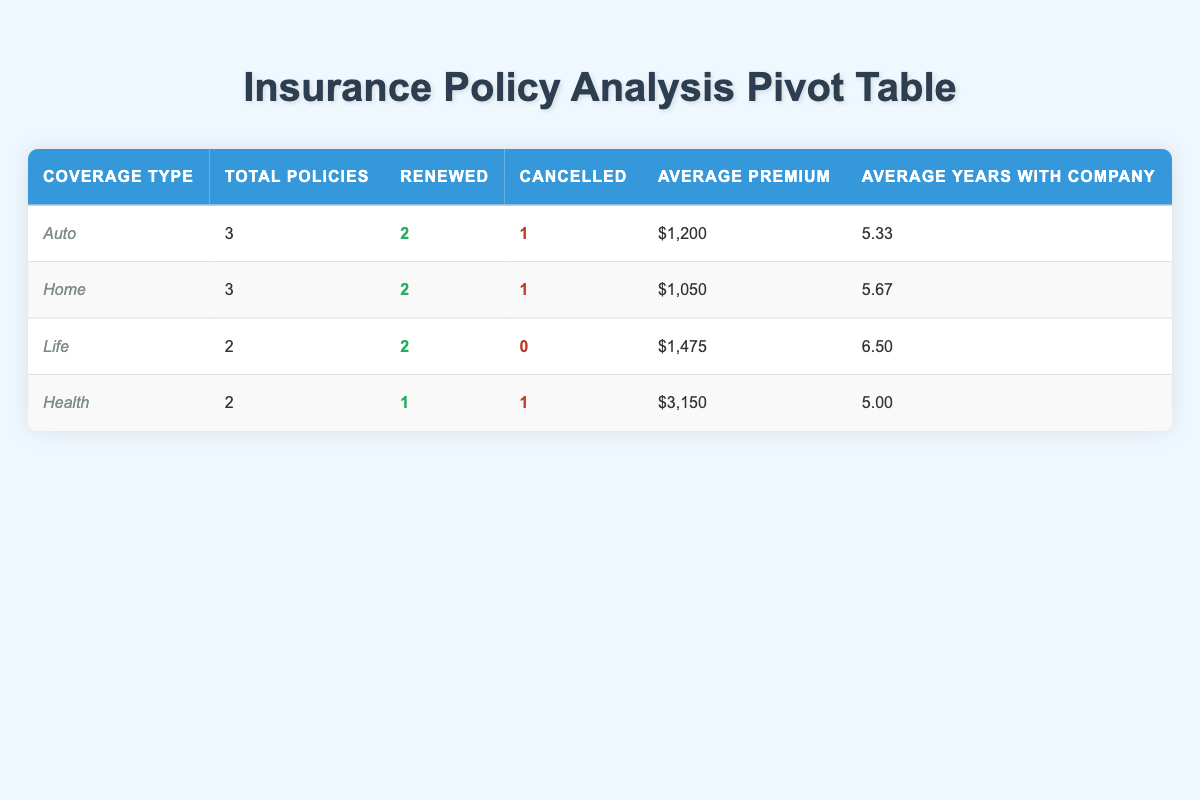What is the total number of policies for Auto coverage? In the table, we can find the row for Auto coverage and see the column labeled "Total Policies," which shows the total number of policies. It states that there are 3 policies for Auto coverage.
Answer: 3 What is the average annual premium for Life insurance? Looking at the row for Life in the table, the column "Average Premium" shows an amount of $1,475. Therefore, that is the average annual premium for Life insurance.
Answer: $1,475 Is the cancellation rate higher for Health insurance compared to Auto insurance? To determine if the cancellation rate for Health is higher than Auto, we compare the "Cancelled" columns. Health has 1 cancelled policy out of 2 total, which gives a cancellation rate of 50%. Auto has 1 cancelled policy out of 3 total, which gives a cancellation rate of approximately 33.33%. Since 50% is greater than 33.33%, the cancellation rate for Health is higher.
Answer: Yes What is the difference in the number of renewed policies between Home and Health insurance? Looking at the renewed policies in the table, Home has 2 renewed policies while Health has 1. To find the difference, we subtract Health's renewed count from Home's: 2 - 1 = 1.
Answer: 1 How many coverage types have more than one policy status, meaning both renewed and cancelled? From the table, we see that Auto, Home, and Health coverage types have both renewed and cancelled statuses. Auto has 2 renewed and 1 cancelled, Home has 2 renewed and 1 cancelled, and Health has 1 renewed and 1 cancelled. Thus, there are 3 coverage types that meet this criterion.
Answer: 3 What is the average number of years customers have been with the company for Home insurance? For Home coverage, the table has two relevant entries: Sarah Johnson has 2 years and Lisa Martinez has 6 years. To find the average, we add these two years (2 + 6 = 8) and divide by the number of policies (2). So, 8 divided by 2 equals 4.
Answer: 4 Does the data show that younger customers (under 30) are more likely to renew their insurance policies compared to those over 30? Checking the table, there is only one customer under 30 (Michael Chen) who renewed his policy. The other customers aged 30 and above include those who have a mix of renewed and cancelled statuses. Since there is no comparative ratio based on age grouping, we cannot definitively say younger customers are more likely to renew based on this data.
Answer: No What is the total annual premium of all cancelled policies? In the table, we look for the cancelled policies. The premiums for cancelled policies are $950 for Home, $1,100 for Auto, and $2,800 for Health. Adding these together gives: 950 + 1100 + 2800 = 4850.
Answer: $4,850 Which coverage type has the highest average annual premium? Looking at the "Average Premium" column, Health has the highest amount at $3,150, compared to Auto at $1,200 and Life at $1,475. Therefore, Health coverage has the highest average premium.
Answer: Health 